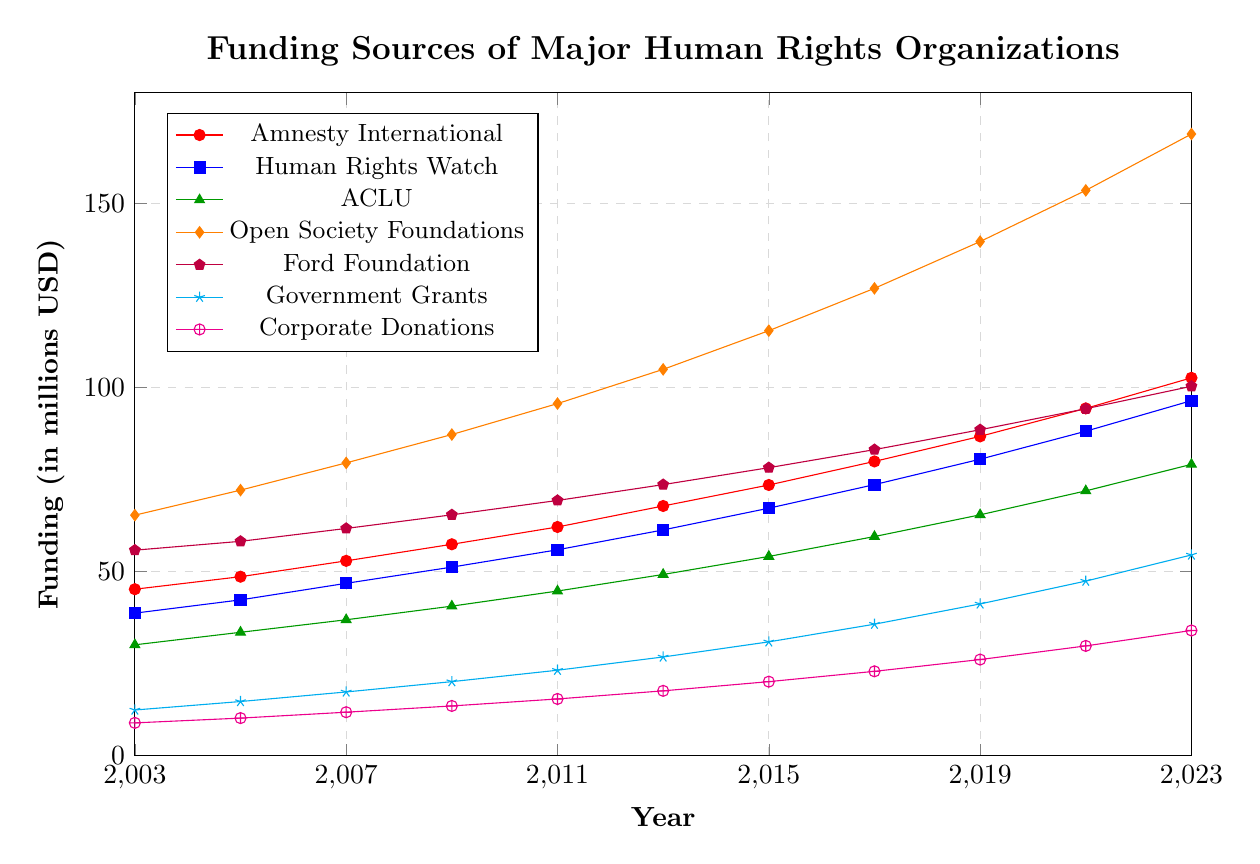What is the overall trend in the funding of Ford Foundation from 2003 to 2023? The funding for Ford Foundation shows a consistent upward trend from 2003 to 2023. The values increase steadily from 55.8 million USD in 2003 to 100.3 million USD in 2023.
Answer: Upward trend Which organization received more funding in 2023, Amnesty International or Human Rights Watch? In 2023, Amnesty International received 102.6 million USD, while Human Rights Watch received 96.4 million USD. Comparing these values shows that Amnesty International received more funding.
Answer: Amnesty International By how much did corporate donations increase from 2003 to 2023? Corporate donations in 2003 were 8.9 million USD and in 2023 were 34.0 million USD. The increase is calculated by subtracting the 2003 value from the 2023 value: 34.0 - 8.9 = 25.1 million USD.
Answer: 25.1 million USD Which funding source had the largest value in 2011 and what was that value? In 2011, the Open Society Foundations had the largest value of 95.6 million USD. By comparing the values from the figure, 95.6 is the highest in that year.
Answer: Open Society Foundations, 95.6 million USD Which funding source exhibited the steepest incline between 2003 and 2013? By visually examining the steepness of the line segments between 2003 and 2013, the Open Society Foundations exhibited the steepest incline, increasing from 65.3 million USD in 2003 to 104.9 million USD in 2013.
Answer: Open Society Foundations In what year did Government Grants exceed 30 million USD? According to the figure, Government Grants first exceeded 30 million USD in 2015, reaching 30.9 million USD.
Answer: 2015 Compare the funding gap between Amnesty International and the ACLU in 2023. In 2023, Amnesty International received 102.6 million USD and the ACLU received 79.1 million USD. The funding gap is 102.6 - 79.1 = 23.5 million USD.
Answer: 23.5 million USD What is the average funding for Human Rights Watch over the entire period from 2003 to 2023? Adding the funding values for Human Rights Watch from 2003 to 2023 (38.7 + 42.3 + 46.8 + 51.2 + 55.9 + 61.3 + 67.2 + 73.6 + 80.5 + 88.1 + 96.4) = 701.0 million USD. Dividing by the number of years (11) gives the average: 701.0 / 11 ≈ 63.7 million USD.
Answer: 63.7 million USD What was the combined funding from Government Grants and Corporate Donations in 2009? Government Grants in 2009 were 20.1 million USD and Corporate Donations were 13.5 million USD. Combining these values gives 20.1 + 13.5 = 33.6 million USD.
Answer: 33.6 million USD 